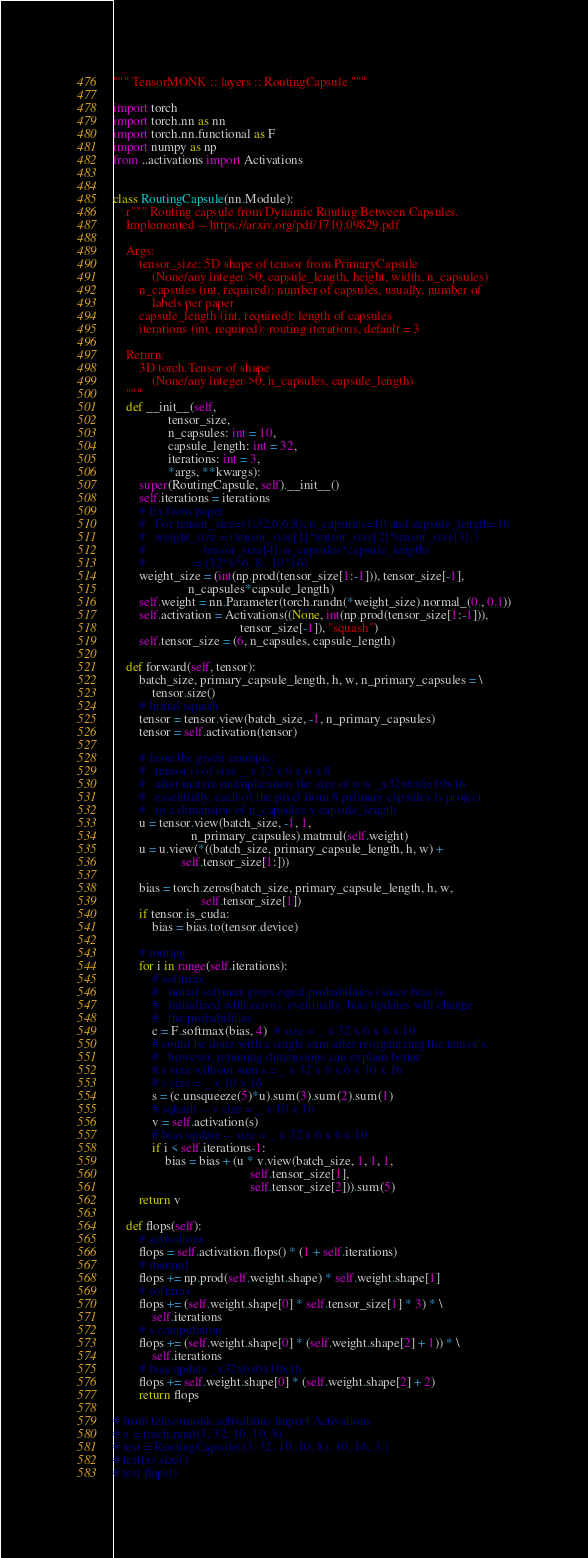<code> <loc_0><loc_0><loc_500><loc_500><_Python_>""" TensorMONK :: layers :: RoutingCapsule """

import torch
import torch.nn as nn
import torch.nn.functional as F
import numpy as np
from ..activations import Activations


class RoutingCapsule(nn.Module):
    r""" Routing capsule from Dynamic Routing Between Capsules.
    Implemented -- https://arxiv.org/pdf/1710.09829.pdf

    Args:
        tensor_size: 5D shape of tensor from PrimaryCapsule
            (None/any integer >0, capsule_length, height, width, n_capsules)
        n_capsules (int, required): number of capsules, usually, number of
            labels per paper
        capsule_length (int, required): length of capsules
        iterations (int, required): routing iterations, default = 3

    Return:
        3D torch.Tensor of shape
            (None/any integer >0, n_capsules, capsule_length)
    """
    def __init__(self,
                 tensor_size,
                 n_capsules: int = 10,
                 capsule_length: int = 32,
                 iterations: int = 3,
                 *args, **kwargs):
        super(RoutingCapsule, self).__init__()
        self.iterations = iterations
        # Ex from paper
        #   For tensor_size=(1,32,6,6,8), n_capsules=10 and capsule_length=16
        #   weight_size = (tensor_size[1]*tensor_size[2]*tensor_size[3], \
        #                  tensor_size[4], n_capsules*capsule_length)
        #               = (32*6*6, 8 , 10*16)
        weight_size = (int(np.prod(tensor_size[1:-1])), tensor_size[-1],
                       n_capsules*capsule_length)
        self.weight = nn.Parameter(torch.randn(*weight_size).normal_(0., 0.1))
        self.activation = Activations((None, int(np.prod(tensor_size[1:-1])),
                                       tensor_size[-1]), "squash")
        self.tensor_size = (6, n_capsules, capsule_length)

    def forward(self, tensor):
        batch_size, primary_capsule_length, h, w, n_primary_capsules = \
            tensor.size()
        # Initial squash
        tensor = tensor.view(batch_size, -1, n_primary_capsules)
        tensor = self.activation(tensor)

        # from the given example:
        #   tensor is of size _ x 32 x 6 x 6 x 8
        #   after matrix mulitplication the size of u is _x32x6x6x10x16
        #   essentially, each of the pixel from 8 primary capsules is project
        #   to a dimension of n_capsules x capsule_length
        u = tensor.view(batch_size, -1, 1,
                        n_primary_capsules).matmul(self.weight)
        u = u.view(*((batch_size, primary_capsule_length, h, w) +
                     self.tensor_size[1:]))

        bias = torch.zeros(batch_size, primary_capsule_length, h, w,
                           self.tensor_size[1])
        if tensor.is_cuda:
            bias = bias.to(tensor.device)

        # routing
        for i in range(self.iterations):
            # softmax
            #   initial softmax gives equal probabilities (since bias is
            #   initialized with zeros), eventually, bias updates will change
            #   the probabilities
            c = F.softmax(bias, 4)  # size = _ x 32 x 6 x 6 x 10
            # could be done with a single sum after reorganizing the tensor's,
            #   however, retaining dimensions can explain better
            # s size without sum's = _ x 32 x 6 x 6 x 10 x 16
            # s size = _ x 10 x 16
            s = (c.unsqueeze(5)*u).sum(3).sum(2).sum(1)
            # squash -- v size = _ x 10 x 16
            v = self.activation(s)
            # bias update -- size = _ x 32 x 6 x 6 x 10
            if i < self.iterations-1:
                bias = bias + (u * v.view(batch_size, 1, 1, 1,
                                          self.tensor_size[1],
                                          self.tensor_size[2])).sum(5)
        return v

    def flops(self):
        # activations
        flops = self.activation.flops() * (1 + self.iterations)
        # matmul
        flops += np.prod(self.weight.shape) * self.weight.shape[1]
        # softmax
        flops += (self.weight.shape[0] * self.tensor_size[1] * 3) * \
            self.iterations
        # s computation
        flops += (self.weight.shape[0] * (self.weight.shape[2] + 1)) * \
            self.iterations
        # bias update _x32x6x6x10x16
        flops += self.weight.shape[0] * (self.weight.shape[2] + 2)
        return flops

# from tensormonk.activations import Activations
# x = torch.rand(3, 32, 10, 10, 8)
# test = RoutingCapsule((3, 32, 10, 10, 8), 10, 16, 3,)
# test(x).size()
# test.flops()
</code> 